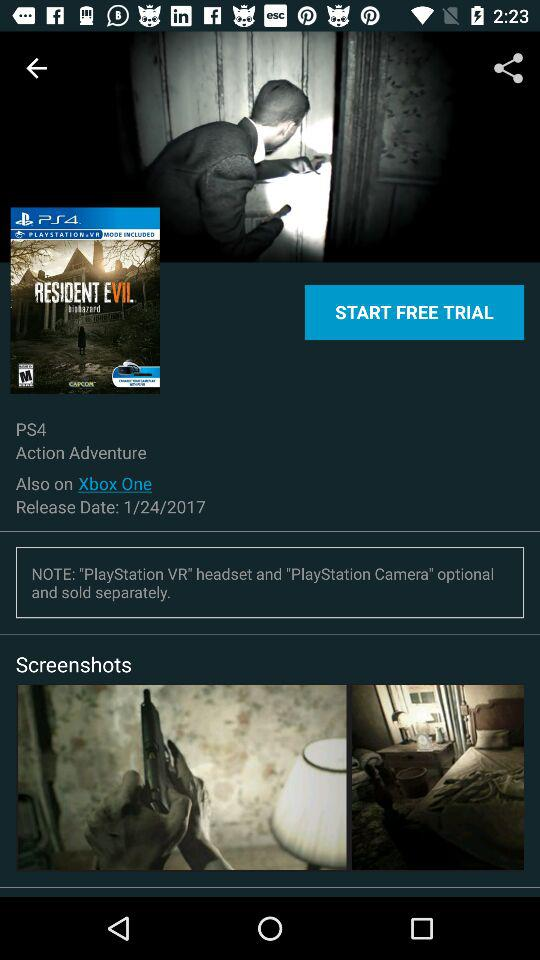How many different platforms can I play this game on?
Answer the question using a single word or phrase. 2 